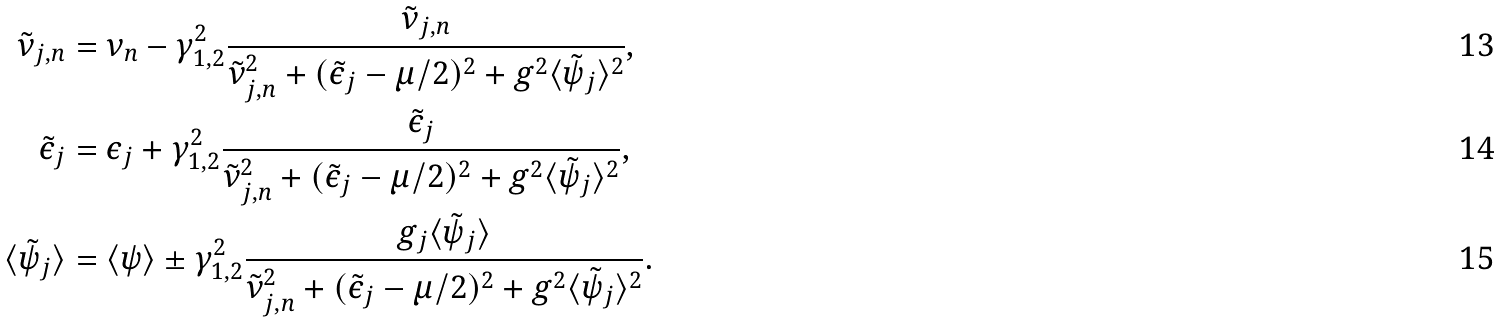Convert formula to latex. <formula><loc_0><loc_0><loc_500><loc_500>\tilde { \nu } _ { j , n } & = \nu _ { n } - \gamma _ { 1 , 2 } ^ { 2 } \frac { \tilde { \nu } _ { j , n } } { \tilde { \nu } _ { j , n } ^ { 2 } + ( \tilde { \epsilon } _ { j } - \mu / 2 ) ^ { 2 } + g ^ { 2 } \langle \tilde { \psi } _ { j } \rangle ^ { 2 } } , \\ \tilde { \epsilon } _ { j } & = \epsilon _ { j } + \gamma _ { 1 , 2 } ^ { 2 } \frac { \tilde { \epsilon } _ { j } } { \tilde { \nu } _ { j , n } ^ { 2 } + ( \tilde { \epsilon } _ { j } - \mu / 2 ) ^ { 2 } + g ^ { 2 } \langle \tilde { \psi } _ { j } \rangle ^ { 2 } } , \\ \langle \tilde { \psi } _ { j } \rangle & = \langle \psi \rangle \pm \gamma _ { 1 , 2 } ^ { 2 } \frac { g _ { j } \langle \tilde { \psi } _ { j } \rangle } { \tilde { \nu } _ { j , n } ^ { 2 } + ( \tilde { \epsilon } _ { j } - \mu / 2 ) ^ { 2 } + g ^ { 2 } \langle \tilde { \psi } _ { j } \rangle ^ { 2 } } .</formula> 